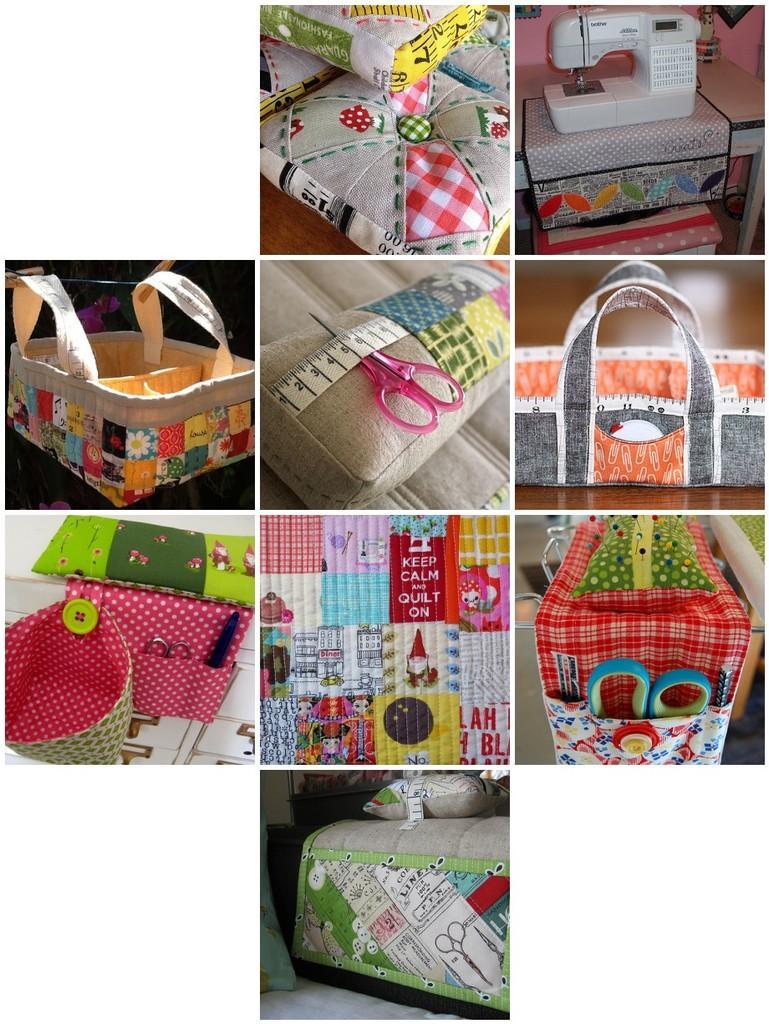Can you describe this image briefly? This is of a collage picture. It looks so colorful. I can see a sewing machine,scissor attached to the pillow,a cloth basket,and I can see a bed with a blanket placed on it. And it looks like a small basket. I can see another scissor which is put inside the cloth. 